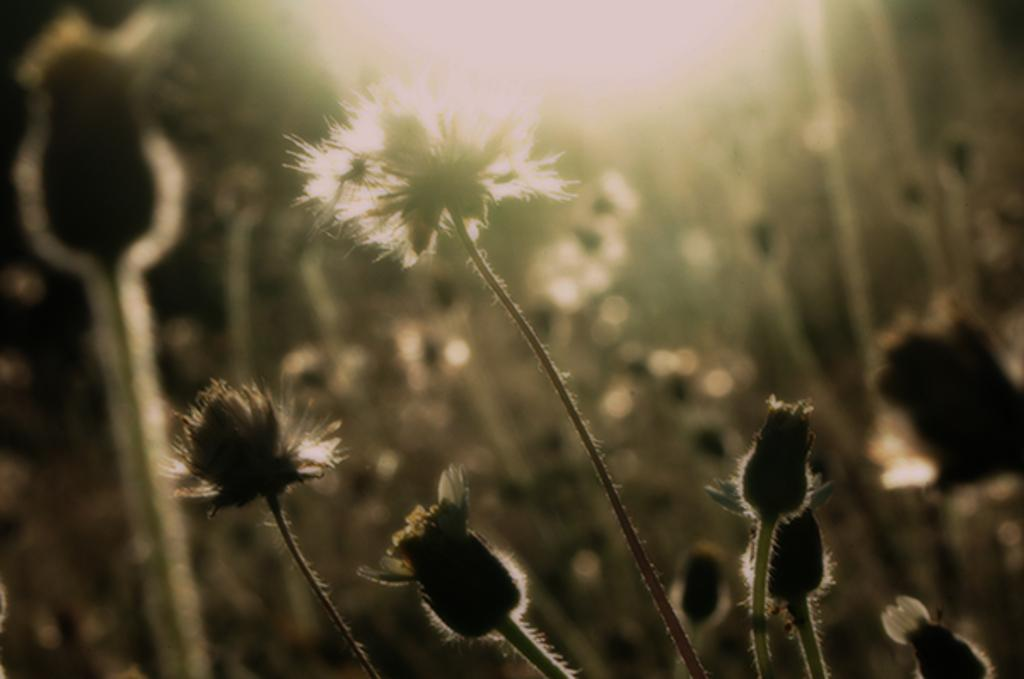What type of plants can be seen in the image? There are flowers in the image. Can you describe the stage of growth for some of the flowers? There are flower buds with stems in the image. What is the appearance of the background in the image? The background of the image is blurry. What source of illumination is present in the image? There is a light in the image. What direction is the ocean flowing in the image? There is no ocean present in the image, so it is not possible to determine the direction of its flow. 